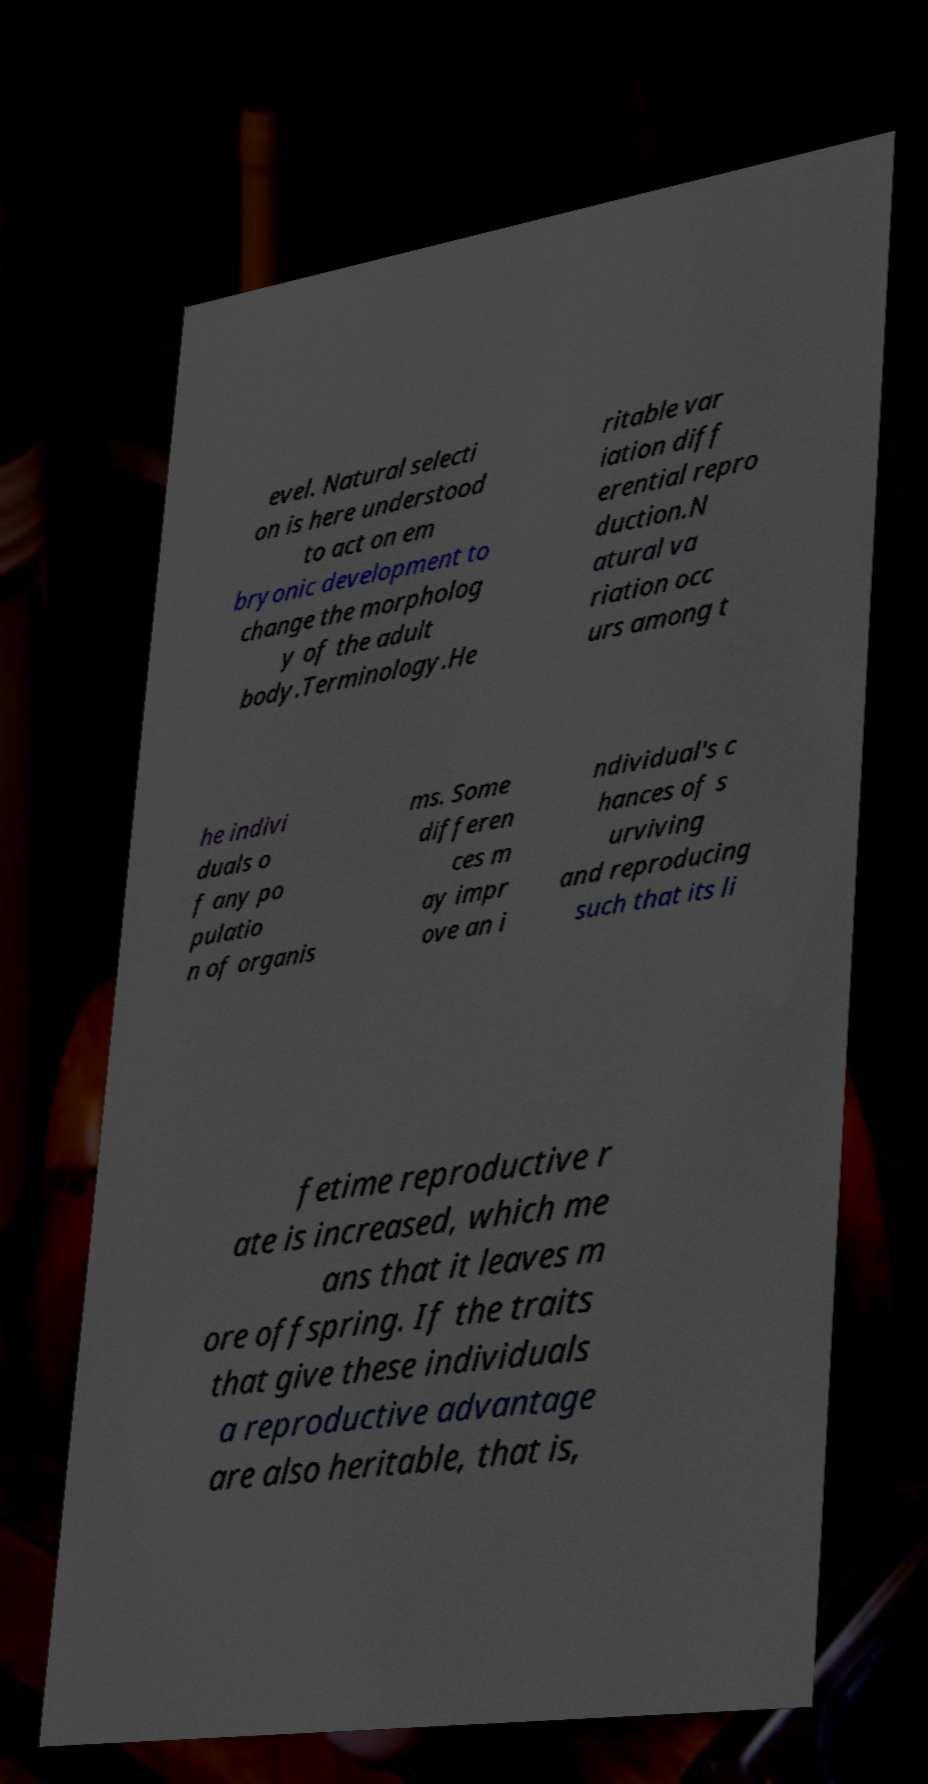For documentation purposes, I need the text within this image transcribed. Could you provide that? evel. Natural selecti on is here understood to act on em bryonic development to change the morpholog y of the adult body.Terminology.He ritable var iation diff erential repro duction.N atural va riation occ urs among t he indivi duals o f any po pulatio n of organis ms. Some differen ces m ay impr ove an i ndividual's c hances of s urviving and reproducing such that its li fetime reproductive r ate is increased, which me ans that it leaves m ore offspring. If the traits that give these individuals a reproductive advantage are also heritable, that is, 